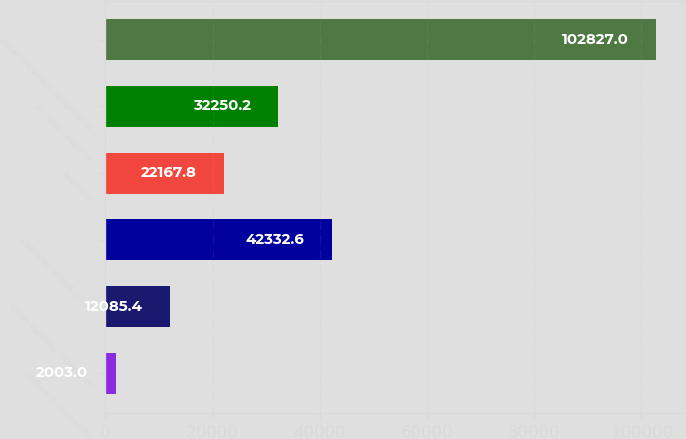<chart> <loc_0><loc_0><loc_500><loc_500><bar_chart><fcel>(dollars in thousands)<fcel>Other liabilities incurred in<fcel>Liabilities settled in the<fcel>Revisions<fcel>Accretion expense<fcel>Asset retirement obligation at<nl><fcel>2003<fcel>12085.4<fcel>42332.6<fcel>22167.8<fcel>32250.2<fcel>102827<nl></chart> 